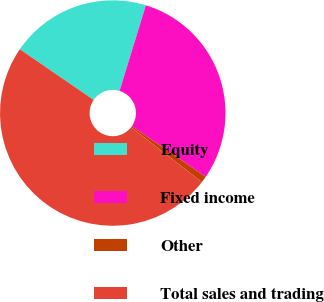Convert chart. <chart><loc_0><loc_0><loc_500><loc_500><pie_chart><fcel>Equity<fcel>Fixed income<fcel>Other<fcel>Total sales and trading<nl><fcel>20.17%<fcel>29.83%<fcel>0.92%<fcel>49.08%<nl></chart> 